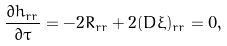<formula> <loc_0><loc_0><loc_500><loc_500>\frac { \partial h _ { r r } } { \partial \tau } = - 2 R _ { r r } + 2 ( D \xi ) _ { r r } = 0 ,</formula> 